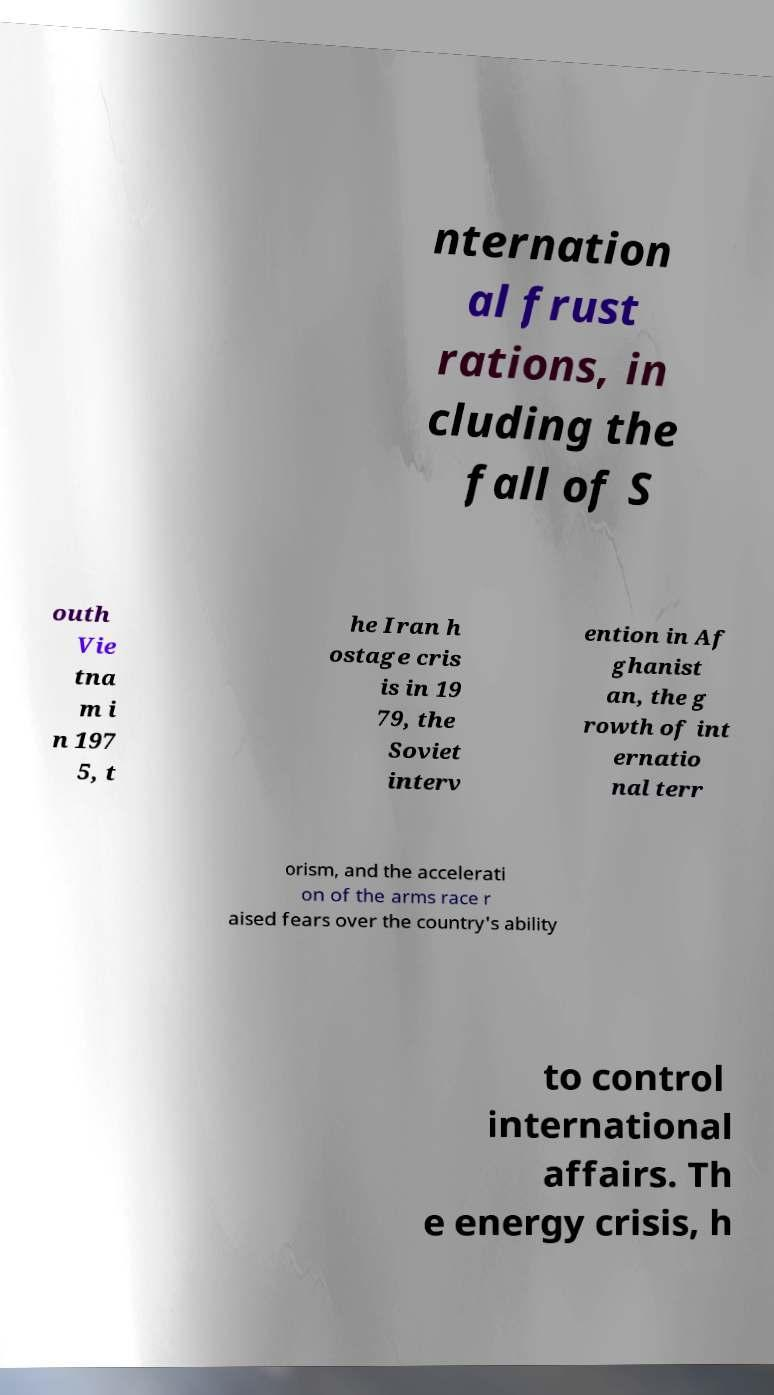Please read and relay the text visible in this image. What does it say? nternation al frust rations, in cluding the fall of S outh Vie tna m i n 197 5, t he Iran h ostage cris is in 19 79, the Soviet interv ention in Af ghanist an, the g rowth of int ernatio nal terr orism, and the accelerati on of the arms race r aised fears over the country's ability to control international affairs. Th e energy crisis, h 